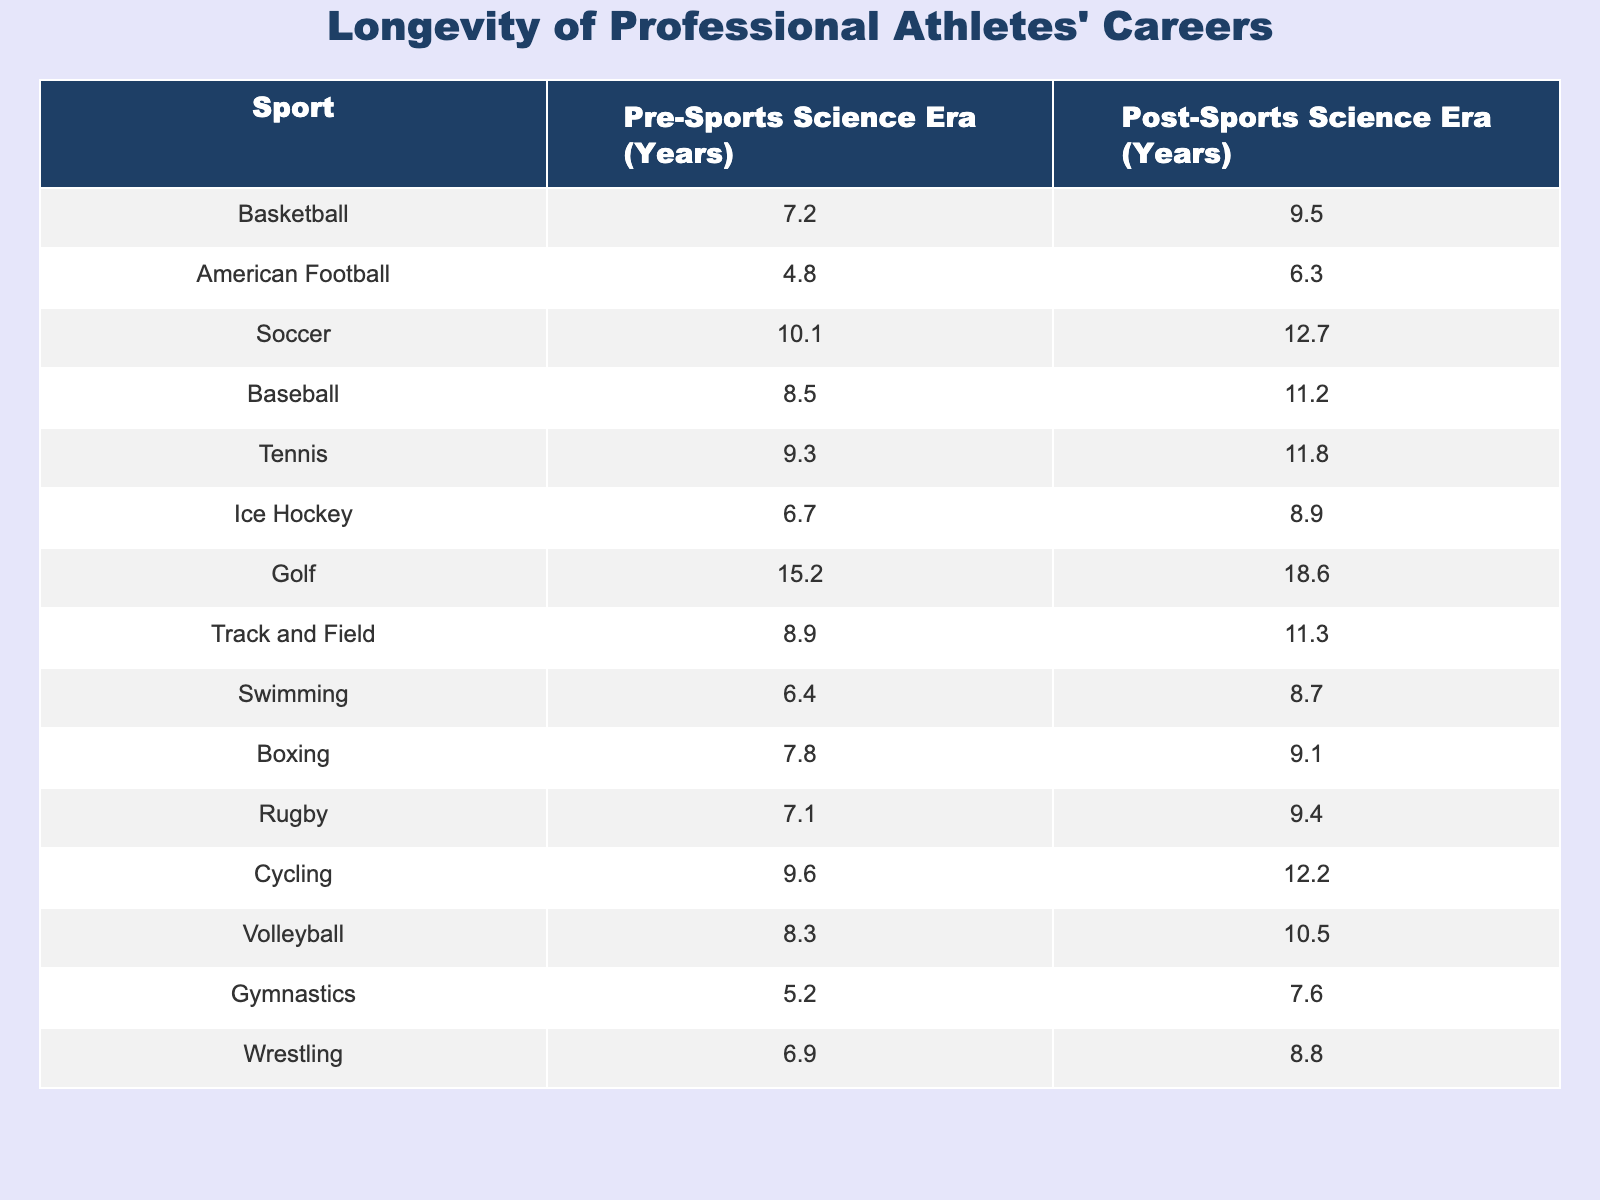What is the longevity of basketball careers after the rise of sports science? The table shows that basketball careers last an average of 9.5 years in the post-sports science era.
Answer: 9.5 years Which sport shows the greatest increase in career longevity from the pre-sports science era to the post-sports science era? By comparing the values, soccer has the largest increase, going from 10.1 years to 12.7 years, resulting in an increase of 2.6 years.
Answer: Soccer What is the average career longevity of volleyball players before the rise of sports science? The table indicates that the pre-sports science era longevity for volleyball players is 8.3 years.
Answer: 8.3 years Does the career longevity of swimming athletes exceed that of wrestling athletes in the post-sports science era? In the post-sports science era, swimming has a career longevity of 8.7 years, while wrestling is at 8.8 years, which means wrestling exceeds swimming.
Answer: No What is the difference in career longevity for golfers before and after the rise of sports science? Golfers have a pre-sports science era longevity of 15.2 years and a post-sports science era longevity of 18.6 years. The difference is 18.6 - 15.2 = 3.4 years.
Answer: 3.4 years What are the average career lengths for baseball and American football players combined after the rise of sports science? Baseball players average 11.2 years and American football players average 6.3 years. The total is 11.2 + 6.3 = 17.5 years, and then dividing by 2 gives an average of 17.5 / 2 = 8.75 years.
Answer: 8.75 years Is the pre-sports science career longevity for track and field athletes greater than that of gymnastics athletes? Track and field athletes have a pre-sports science longevity of 8.9 years, while gymnastics athletes have 5.2 years. Since 8.9 > 5.2, the answer is yes.
Answer: Yes What is the trend in career longevity from the pre-sports science era to the post-sports science era across all sports? Observing the data, all sports show an increase in career longevity after the rise of sports science.
Answer: All sports show an increase Which sport has the shortest career longevity in the pre-sports science era according to the data? The table indicates that gymnastics has the shortest career longevity in the pre-sports science era at 5.2 years.
Answer: Gymnastics What is the average career longevity pre-sports science for the team sports listed (American Football, Soccer, Ice Hockey, Rugby, Volleyball)? The pre-sports science career lengths for the team sports are 4.8, 10.1, 6.7, 7.1, and 8.3 years. The total is 4.8 + 10.1 + 6.7 + 7.1 + 8.3 = 37.0 years, and dividing by 5 gives an average of 37.0 / 5 = 7.4 years.
Answer: 7.4 years 